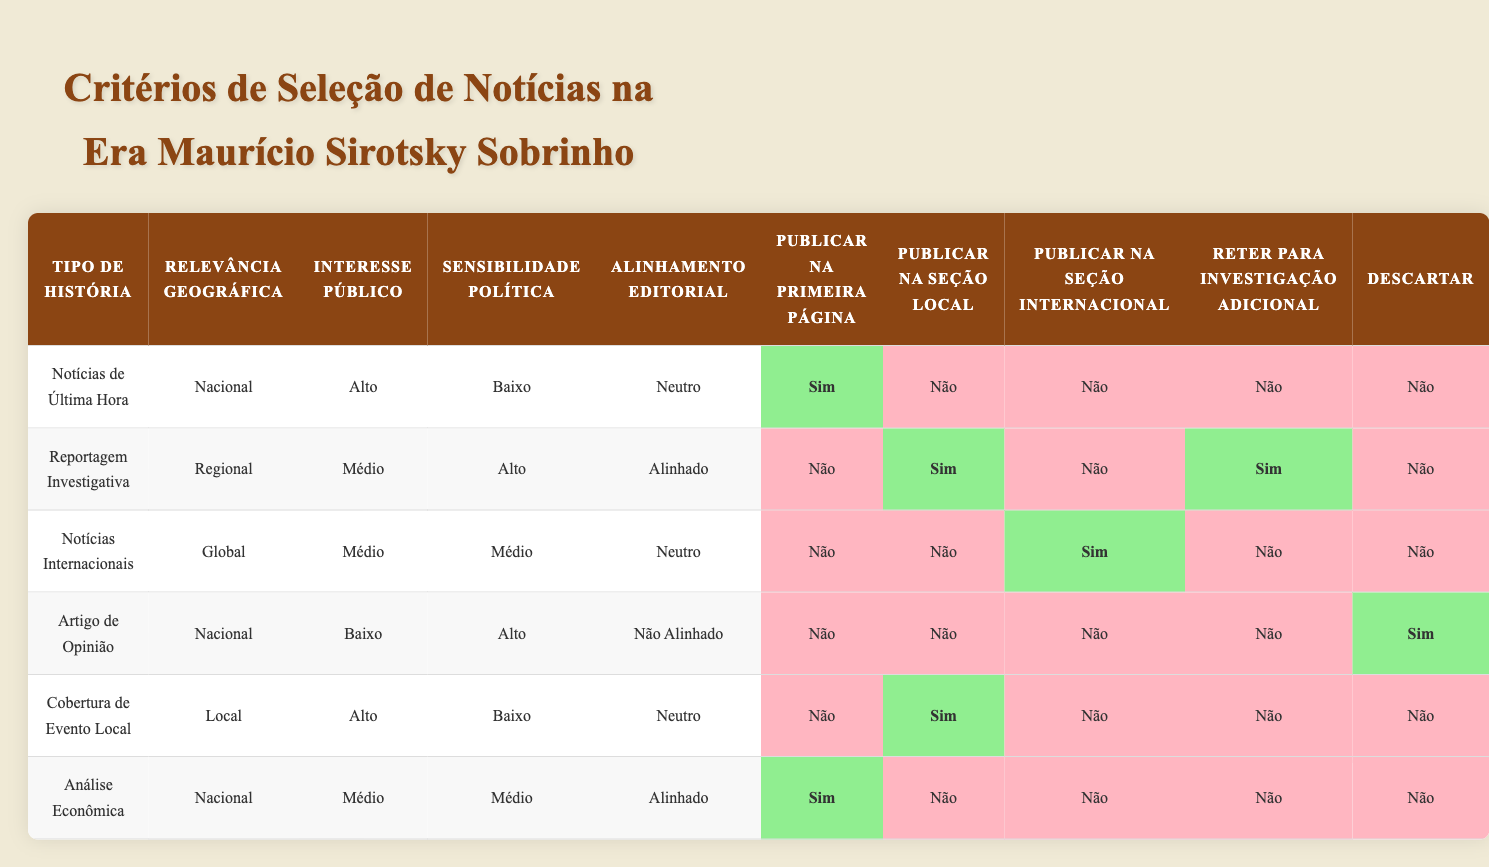What type of story has the highest public interest score? In the table, we look for 'Public Interest' values. "Notícias de Última Hora" has "Alto" (High) as its interest level, which is the highest listed.
Answer: Notícias de Última Hora Which story types are published in the local section? Scanning the "Publicar na Seção Local" column, we find "Reportagem Investigativa" and "Cobertura de Evento Local" marked as "Sim".
Answer: Reportagem Investigativa, Cobertura de Evento Local Is "Análise Econômica" published on the front page? Check the "Publicar na Primeira Página" column for "Análise Econômica", which shows "Sim".
Answer: Sim What is the total number of stories that can be published on the front page? From the "Publicar na Primeira Página" column, we see "Notícias de Última Hora" and "Análise Econômica" can be published there. Thus, the total is 2.
Answer: 2 Are there any stories that are discarded? Looking at the "Descartar" column, only "Artigo de Opinião" is marked as "Sim", indicating it is the only story type discarded.
Answer: Sim Which type of story is retained for further investigation? In the "Reter para Investigação Adicional" column, "Reportagem Investigativa" is the only type marked as "Sim".
Answer: Reportagem Investigativa How many story types have a high public interest? The table indicates that only "Notícias de Última Hora" and "Cobertura de Evento Local" have "Alto" (High) public interest, giving us a total of 2.
Answer: 2 Which story types are not published in any section? We look at "Publicar na Seção Local," "Publicar na Seção Internacional," and "Publicar na Primeira Página." "Artigo de Opinião" is not published in any section, marked as "Não".
Answer: Artigo de Opinião What is the political sensitivity level of "Notícias Internacionais"? The political sensitivity for "Notícias Internacionais" is listed as "Médio" (Medium) in the relevant column.
Answer: Médio 